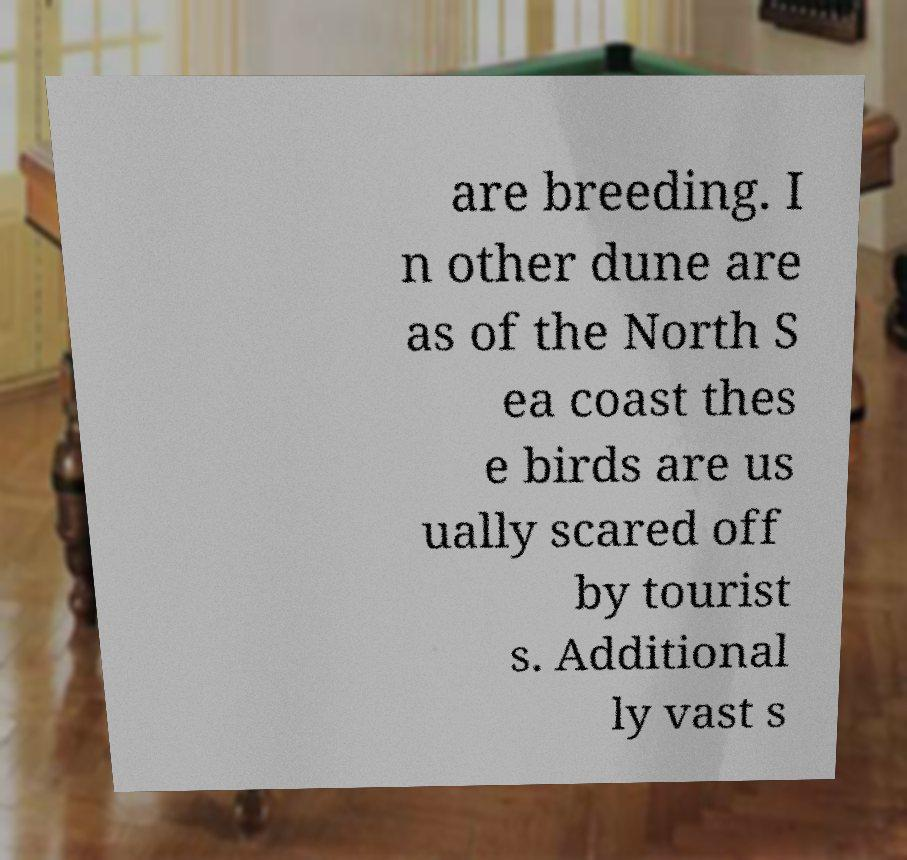Can you read and provide the text displayed in the image?This photo seems to have some interesting text. Can you extract and type it out for me? are breeding. I n other dune are as of the North S ea coast thes e birds are us ually scared off by tourist s. Additional ly vast s 